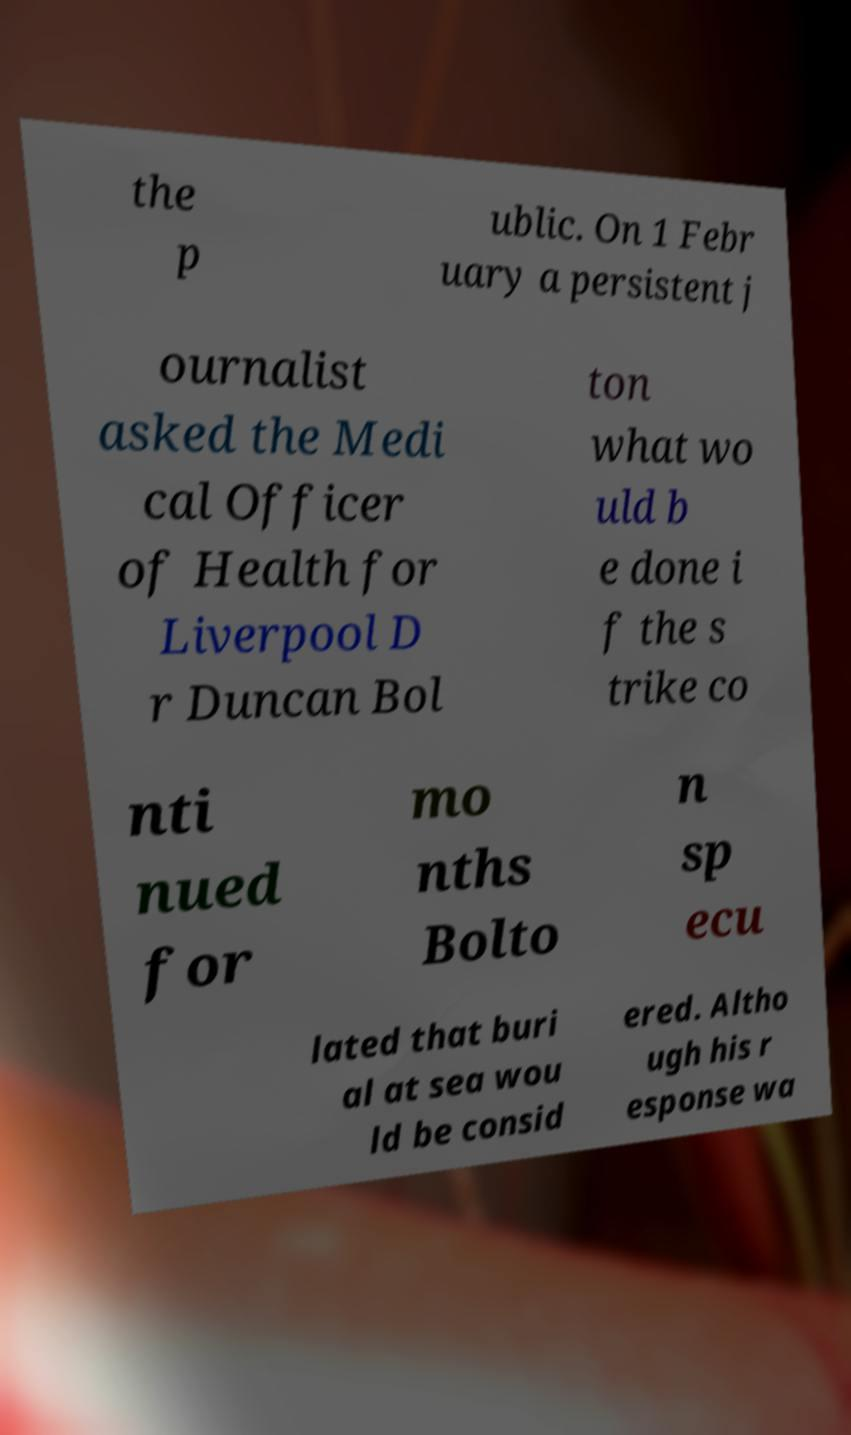I need the written content from this picture converted into text. Can you do that? the p ublic. On 1 Febr uary a persistent j ournalist asked the Medi cal Officer of Health for Liverpool D r Duncan Bol ton what wo uld b e done i f the s trike co nti nued for mo nths Bolto n sp ecu lated that buri al at sea wou ld be consid ered. Altho ugh his r esponse wa 